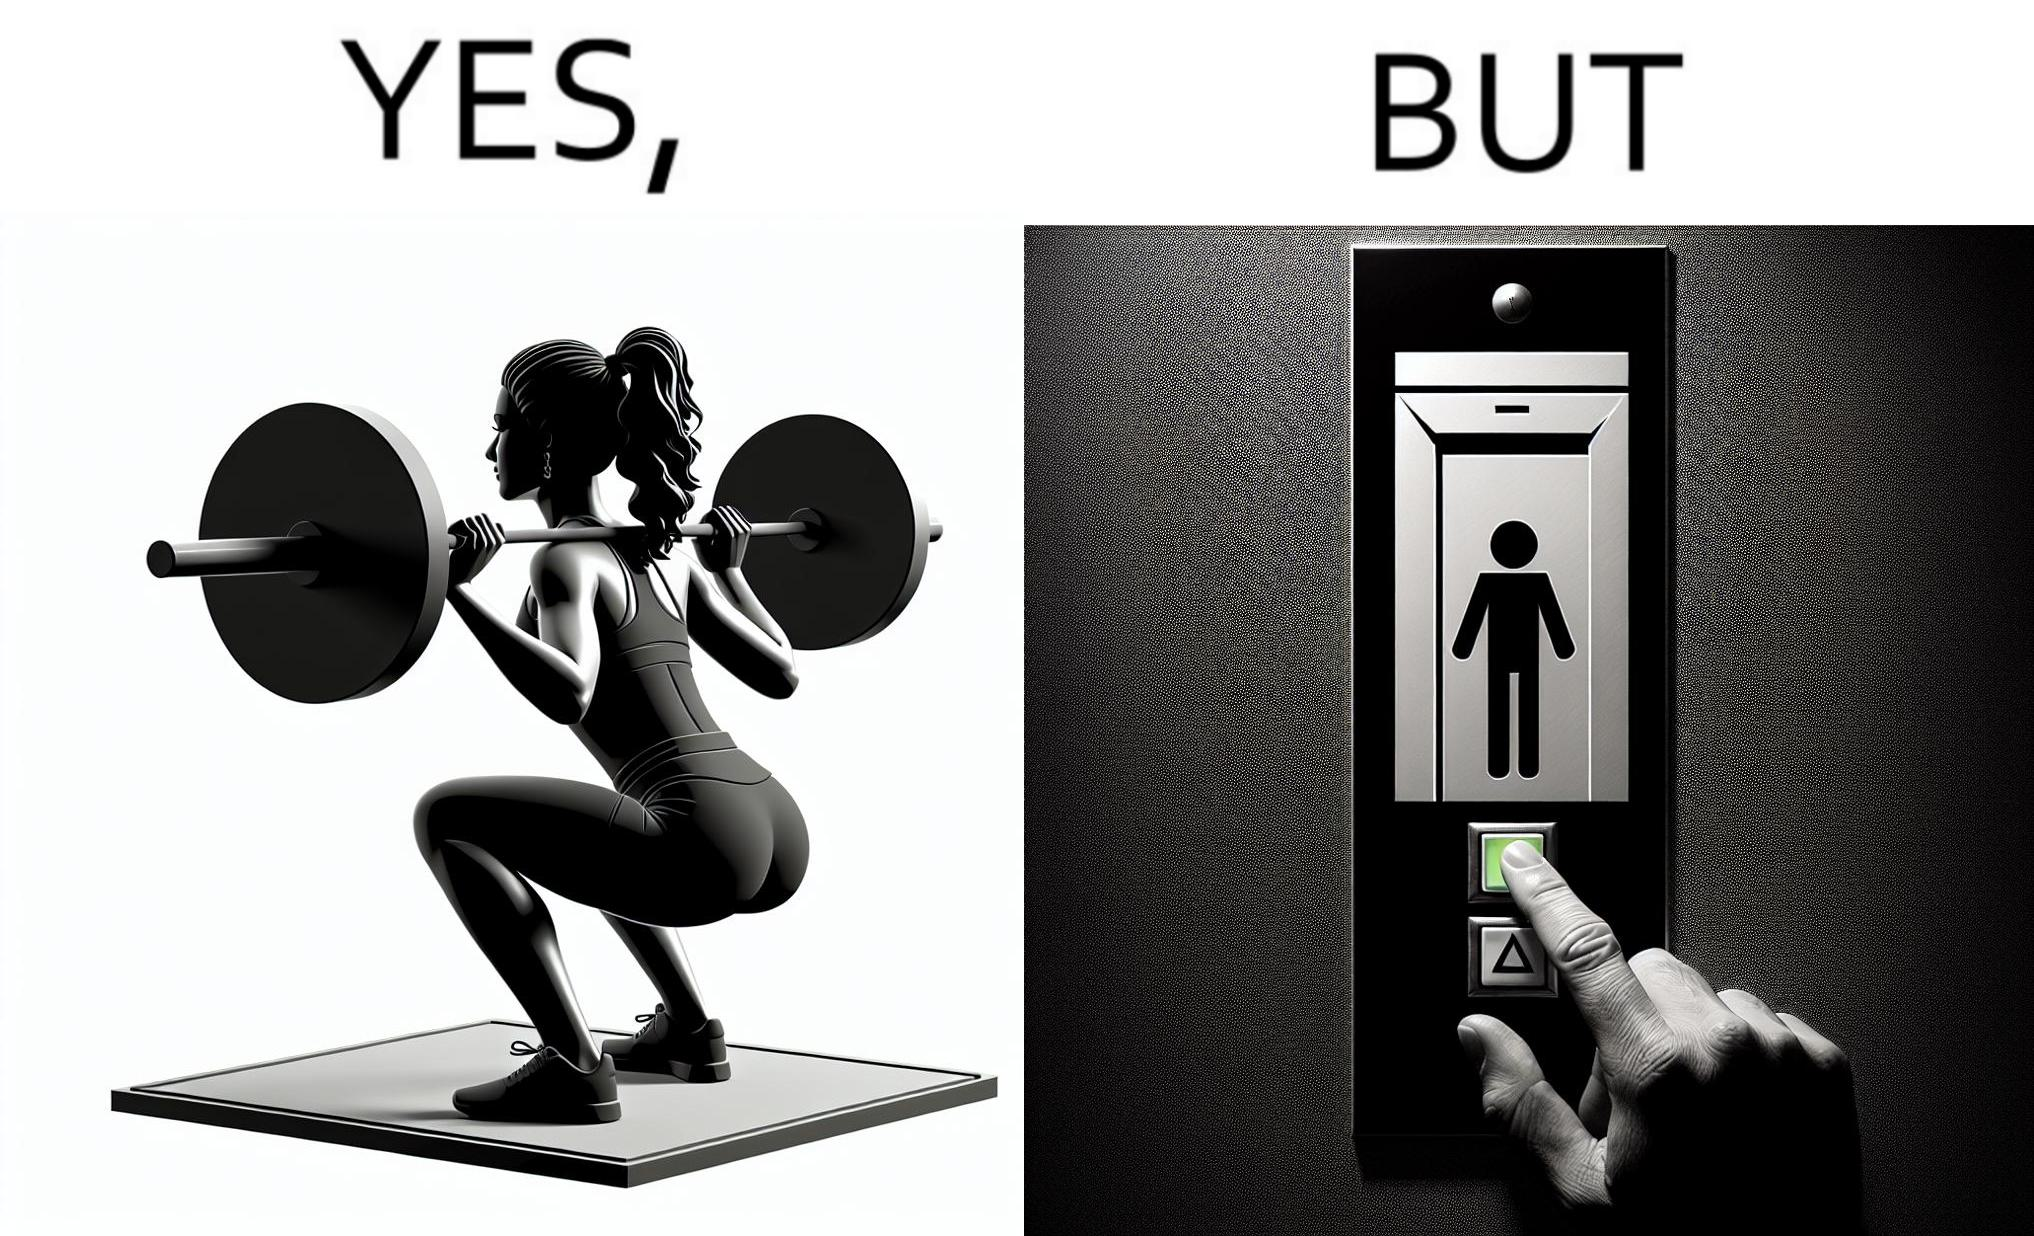Compare the left and right sides of this image. In the left part of the image: The image shows a women exercising with a bar bell in a gym. She is wearing a sport outfit. She is crouching down on one leg doing a single leg squat with a bar bell. In the right part of the image: The image shows the control panel inside of an elevator. The indicator for the first floor is green which means the button for the first floor was pressed. A hand is about to press the button for the second floor. 